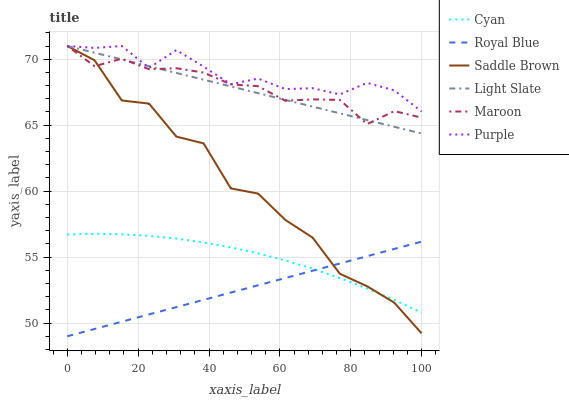Does Royal Blue have the minimum area under the curve?
Answer yes or no. Yes. Does Purple have the maximum area under the curve?
Answer yes or no. Yes. Does Light Slate have the minimum area under the curve?
Answer yes or no. No. Does Light Slate have the maximum area under the curve?
Answer yes or no. No. Is Royal Blue the smoothest?
Answer yes or no. Yes. Is Saddle Brown the roughest?
Answer yes or no. Yes. Is Light Slate the smoothest?
Answer yes or no. No. Is Light Slate the roughest?
Answer yes or no. No. Does Royal Blue have the lowest value?
Answer yes or no. Yes. Does Light Slate have the lowest value?
Answer yes or no. No. Does Saddle Brown have the highest value?
Answer yes or no. Yes. Does Cyan have the highest value?
Answer yes or no. No. Is Royal Blue less than Maroon?
Answer yes or no. Yes. Is Light Slate greater than Royal Blue?
Answer yes or no. Yes. Does Saddle Brown intersect Purple?
Answer yes or no. Yes. Is Saddle Brown less than Purple?
Answer yes or no. No. Is Saddle Brown greater than Purple?
Answer yes or no. No. Does Royal Blue intersect Maroon?
Answer yes or no. No. 